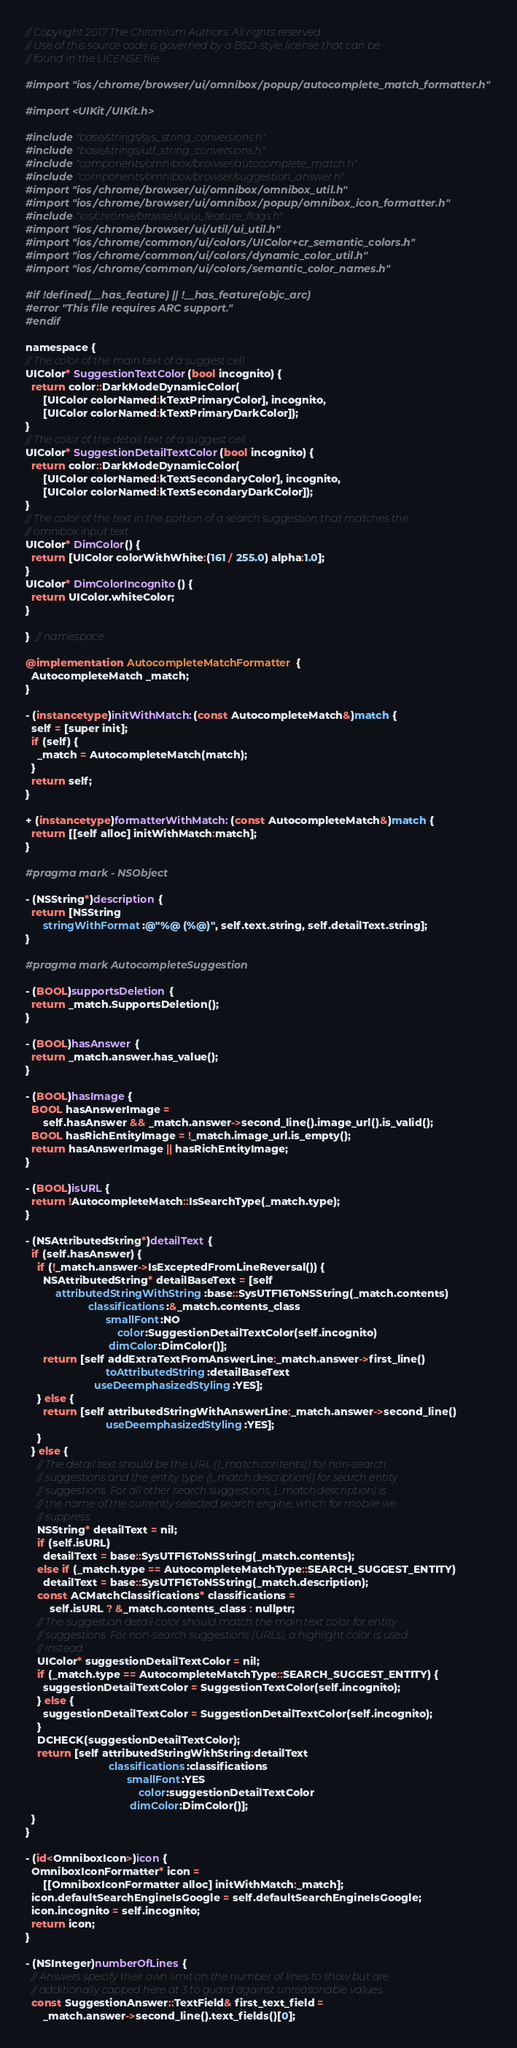<code> <loc_0><loc_0><loc_500><loc_500><_ObjectiveC_>// Copyright 2017 The Chromium Authors. All rights reserved.
// Use of this source code is governed by a BSD-style license that can be
// found in the LICENSE file.

#import "ios/chrome/browser/ui/omnibox/popup/autocomplete_match_formatter.h"

#import <UIKit/UIKit.h>

#include "base/strings/sys_string_conversions.h"
#include "base/strings/utf_string_conversions.h"
#include "components/omnibox/browser/autocomplete_match.h"
#include "components/omnibox/browser/suggestion_answer.h"
#import "ios/chrome/browser/ui/omnibox/omnibox_util.h"
#import "ios/chrome/browser/ui/omnibox/popup/omnibox_icon_formatter.h"
#include "ios/chrome/browser/ui/ui_feature_flags.h"
#import "ios/chrome/browser/ui/util/ui_util.h"
#import "ios/chrome/common/ui/colors/UIColor+cr_semantic_colors.h"
#import "ios/chrome/common/ui/colors/dynamic_color_util.h"
#import "ios/chrome/common/ui/colors/semantic_color_names.h"

#if !defined(__has_feature) || !__has_feature(objc_arc)
#error "This file requires ARC support."
#endif

namespace {
// The color of the main text of a suggest cell.
UIColor* SuggestionTextColor(bool incognito) {
  return color::DarkModeDynamicColor(
      [UIColor colorNamed:kTextPrimaryColor], incognito,
      [UIColor colorNamed:kTextPrimaryDarkColor]);
}
// The color of the detail text of a suggest cell.
UIColor* SuggestionDetailTextColor(bool incognito) {
  return color::DarkModeDynamicColor(
      [UIColor colorNamed:kTextSecondaryColor], incognito,
      [UIColor colorNamed:kTextSecondaryDarkColor]);
}
// The color of the text in the portion of a search suggestion that matches the
// omnibox input text.
UIColor* DimColor() {
  return [UIColor colorWithWhite:(161 / 255.0) alpha:1.0];
}
UIColor* DimColorIncognito() {
  return UIColor.whiteColor;
}

}  // namespace

@implementation AutocompleteMatchFormatter {
  AutocompleteMatch _match;
}

- (instancetype)initWithMatch:(const AutocompleteMatch&)match {
  self = [super init];
  if (self) {
    _match = AutocompleteMatch(match);
  }
  return self;
}

+ (instancetype)formatterWithMatch:(const AutocompleteMatch&)match {
  return [[self alloc] initWithMatch:match];
}

#pragma mark - NSObject

- (NSString*)description {
  return [NSString
      stringWithFormat:@"%@ (%@)", self.text.string, self.detailText.string];
}

#pragma mark AutocompleteSuggestion

- (BOOL)supportsDeletion {
  return _match.SupportsDeletion();
}

- (BOOL)hasAnswer {
  return _match.answer.has_value();
}

- (BOOL)hasImage {
  BOOL hasAnswerImage =
      self.hasAnswer && _match.answer->second_line().image_url().is_valid();
  BOOL hasRichEntityImage = !_match.image_url.is_empty();
  return hasAnswerImage || hasRichEntityImage;
}

- (BOOL)isURL {
  return !AutocompleteMatch::IsSearchType(_match.type);
}

- (NSAttributedString*)detailText {
  if (self.hasAnswer) {
    if (!_match.answer->IsExceptedFromLineReversal()) {
      NSAttributedString* detailBaseText = [self
          attributedStringWithString:base::SysUTF16ToNSString(_match.contents)
                     classifications:&_match.contents_class
                           smallFont:NO
                               color:SuggestionDetailTextColor(self.incognito)
                            dimColor:DimColor()];
      return [self addExtraTextFromAnswerLine:_match.answer->first_line()
                           toAttributedString:detailBaseText
                       useDeemphasizedStyling:YES];
    } else {
      return [self attributedStringWithAnswerLine:_match.answer->second_line()
                           useDeemphasizedStyling:YES];
    }
  } else {
    // The detail text should be the URL (|_match.contents|) for non-search
    // suggestions and the entity type (|_match.description|) for search entity
    // suggestions. For all other search suggestions, |_match.description| is
    // the name of the currently selected search engine, which for mobile we
    // suppress.
    NSString* detailText = nil;
    if (self.isURL)
      detailText = base::SysUTF16ToNSString(_match.contents);
    else if (_match.type == AutocompleteMatchType::SEARCH_SUGGEST_ENTITY)
      detailText = base::SysUTF16ToNSString(_match.description);
    const ACMatchClassifications* classifications =
        self.isURL ? &_match.contents_class : nullptr;
    // The suggestion detail color should match the main text color for entity
    // suggestions. For non-search suggestions (URLs), a highlight color is used
    // instead.
    UIColor* suggestionDetailTextColor = nil;
    if (_match.type == AutocompleteMatchType::SEARCH_SUGGEST_ENTITY) {
      suggestionDetailTextColor = SuggestionTextColor(self.incognito);
    } else {
      suggestionDetailTextColor = SuggestionDetailTextColor(self.incognito);
    }
    DCHECK(suggestionDetailTextColor);
    return [self attributedStringWithString:detailText
                            classifications:classifications
                                  smallFont:YES
                                      color:suggestionDetailTextColor
                                   dimColor:DimColor()];
  }
}

- (id<OmniboxIcon>)icon {
  OmniboxIconFormatter* icon =
      [[OmniboxIconFormatter alloc] initWithMatch:_match];
  icon.defaultSearchEngineIsGoogle = self.defaultSearchEngineIsGoogle;
  icon.incognito = self.incognito;
  return icon;
}

- (NSInteger)numberOfLines {
  // Answers specify their own limit on the number of lines to show but are
  // additionally capped here at 3 to guard against unreasonable values.
  const SuggestionAnswer::TextField& first_text_field =
      _match.answer->second_line().text_fields()[0];</code> 